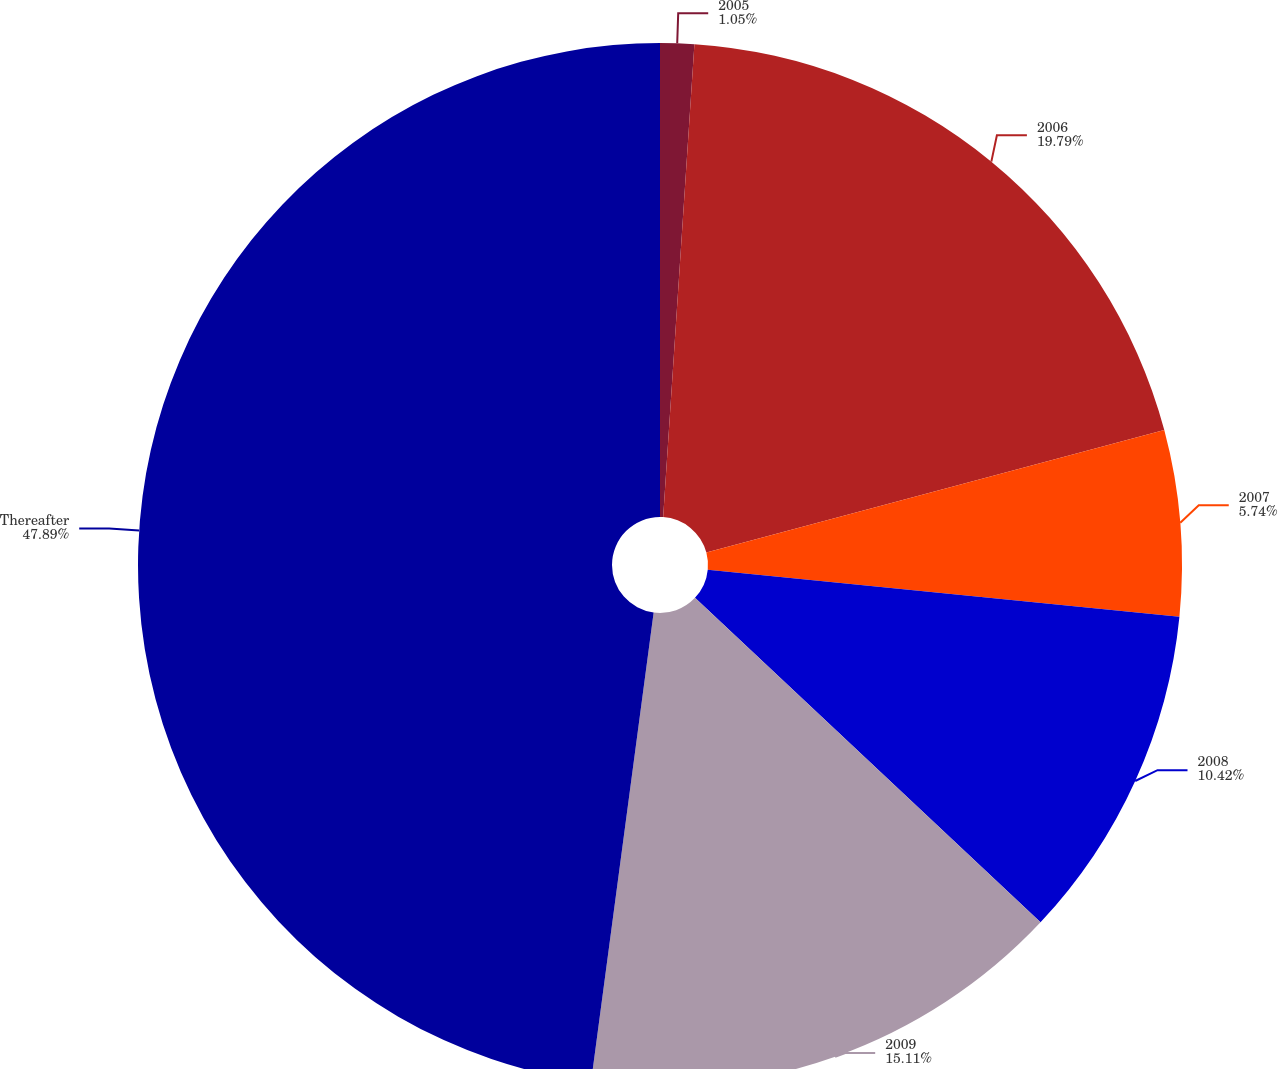<chart> <loc_0><loc_0><loc_500><loc_500><pie_chart><fcel>2005<fcel>2006<fcel>2007<fcel>2008<fcel>2009<fcel>Thereafter<nl><fcel>1.05%<fcel>19.79%<fcel>5.74%<fcel>10.42%<fcel>15.11%<fcel>47.89%<nl></chart> 